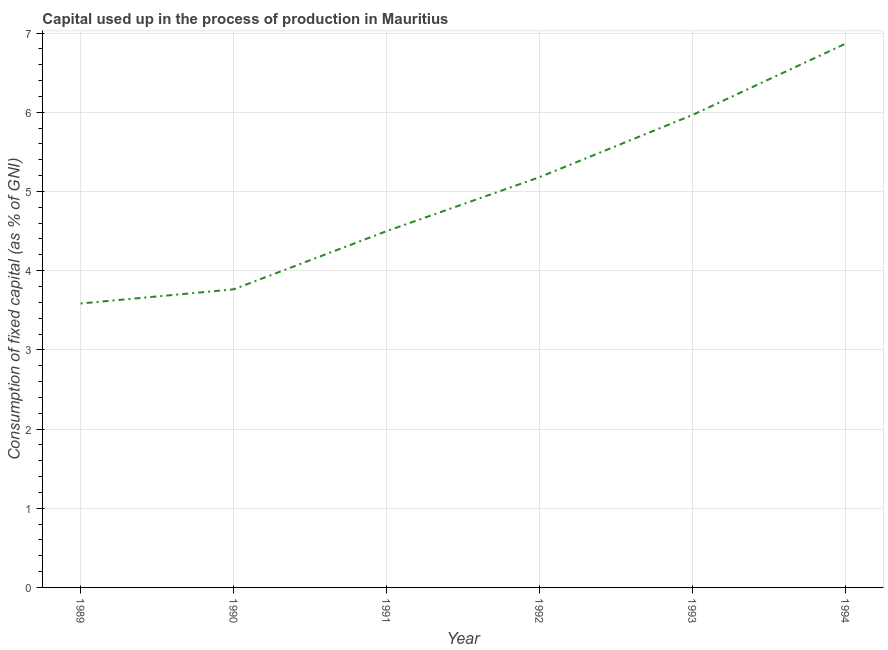What is the consumption of fixed capital in 1991?
Your response must be concise. 4.5. Across all years, what is the maximum consumption of fixed capital?
Keep it short and to the point. 6.86. Across all years, what is the minimum consumption of fixed capital?
Offer a very short reply. 3.59. What is the sum of the consumption of fixed capital?
Ensure brevity in your answer.  29.86. What is the difference between the consumption of fixed capital in 1989 and 1994?
Your response must be concise. -3.28. What is the average consumption of fixed capital per year?
Give a very brief answer. 4.98. What is the median consumption of fixed capital?
Offer a terse response. 4.84. Do a majority of the years between 1993 and 1994 (inclusive) have consumption of fixed capital greater than 4.2 %?
Your response must be concise. Yes. What is the ratio of the consumption of fixed capital in 1990 to that in 1993?
Your answer should be very brief. 0.63. What is the difference between the highest and the second highest consumption of fixed capital?
Keep it short and to the point. 0.9. Is the sum of the consumption of fixed capital in 1989 and 1994 greater than the maximum consumption of fixed capital across all years?
Your answer should be compact. Yes. What is the difference between the highest and the lowest consumption of fixed capital?
Provide a succinct answer. 3.28. How many years are there in the graph?
Provide a short and direct response. 6. What is the difference between two consecutive major ticks on the Y-axis?
Make the answer very short. 1. What is the title of the graph?
Your answer should be very brief. Capital used up in the process of production in Mauritius. What is the label or title of the Y-axis?
Your response must be concise. Consumption of fixed capital (as % of GNI). What is the Consumption of fixed capital (as % of GNI) of 1989?
Keep it short and to the point. 3.59. What is the Consumption of fixed capital (as % of GNI) of 1990?
Provide a succinct answer. 3.76. What is the Consumption of fixed capital (as % of GNI) of 1991?
Offer a very short reply. 4.5. What is the Consumption of fixed capital (as % of GNI) in 1992?
Provide a short and direct response. 5.18. What is the Consumption of fixed capital (as % of GNI) in 1993?
Your answer should be very brief. 5.96. What is the Consumption of fixed capital (as % of GNI) in 1994?
Ensure brevity in your answer.  6.86. What is the difference between the Consumption of fixed capital (as % of GNI) in 1989 and 1990?
Your response must be concise. -0.18. What is the difference between the Consumption of fixed capital (as % of GNI) in 1989 and 1991?
Your response must be concise. -0.91. What is the difference between the Consumption of fixed capital (as % of GNI) in 1989 and 1992?
Offer a terse response. -1.59. What is the difference between the Consumption of fixed capital (as % of GNI) in 1989 and 1993?
Keep it short and to the point. -2.38. What is the difference between the Consumption of fixed capital (as % of GNI) in 1989 and 1994?
Keep it short and to the point. -3.28. What is the difference between the Consumption of fixed capital (as % of GNI) in 1990 and 1991?
Give a very brief answer. -0.73. What is the difference between the Consumption of fixed capital (as % of GNI) in 1990 and 1992?
Ensure brevity in your answer.  -1.42. What is the difference between the Consumption of fixed capital (as % of GNI) in 1990 and 1993?
Ensure brevity in your answer.  -2.2. What is the difference between the Consumption of fixed capital (as % of GNI) in 1990 and 1994?
Give a very brief answer. -3.1. What is the difference between the Consumption of fixed capital (as % of GNI) in 1991 and 1992?
Give a very brief answer. -0.68. What is the difference between the Consumption of fixed capital (as % of GNI) in 1991 and 1993?
Your answer should be very brief. -1.47. What is the difference between the Consumption of fixed capital (as % of GNI) in 1991 and 1994?
Your answer should be very brief. -2.37. What is the difference between the Consumption of fixed capital (as % of GNI) in 1992 and 1993?
Provide a succinct answer. -0.79. What is the difference between the Consumption of fixed capital (as % of GNI) in 1992 and 1994?
Make the answer very short. -1.68. What is the difference between the Consumption of fixed capital (as % of GNI) in 1993 and 1994?
Provide a succinct answer. -0.9. What is the ratio of the Consumption of fixed capital (as % of GNI) in 1989 to that in 1990?
Give a very brief answer. 0.95. What is the ratio of the Consumption of fixed capital (as % of GNI) in 1989 to that in 1991?
Make the answer very short. 0.8. What is the ratio of the Consumption of fixed capital (as % of GNI) in 1989 to that in 1992?
Make the answer very short. 0.69. What is the ratio of the Consumption of fixed capital (as % of GNI) in 1989 to that in 1993?
Ensure brevity in your answer.  0.6. What is the ratio of the Consumption of fixed capital (as % of GNI) in 1989 to that in 1994?
Give a very brief answer. 0.52. What is the ratio of the Consumption of fixed capital (as % of GNI) in 1990 to that in 1991?
Offer a very short reply. 0.84. What is the ratio of the Consumption of fixed capital (as % of GNI) in 1990 to that in 1992?
Provide a succinct answer. 0.73. What is the ratio of the Consumption of fixed capital (as % of GNI) in 1990 to that in 1993?
Make the answer very short. 0.63. What is the ratio of the Consumption of fixed capital (as % of GNI) in 1990 to that in 1994?
Offer a terse response. 0.55. What is the ratio of the Consumption of fixed capital (as % of GNI) in 1991 to that in 1992?
Ensure brevity in your answer.  0.87. What is the ratio of the Consumption of fixed capital (as % of GNI) in 1991 to that in 1993?
Offer a terse response. 0.75. What is the ratio of the Consumption of fixed capital (as % of GNI) in 1991 to that in 1994?
Your answer should be compact. 0.66. What is the ratio of the Consumption of fixed capital (as % of GNI) in 1992 to that in 1993?
Give a very brief answer. 0.87. What is the ratio of the Consumption of fixed capital (as % of GNI) in 1992 to that in 1994?
Your answer should be compact. 0.76. What is the ratio of the Consumption of fixed capital (as % of GNI) in 1993 to that in 1994?
Keep it short and to the point. 0.87. 